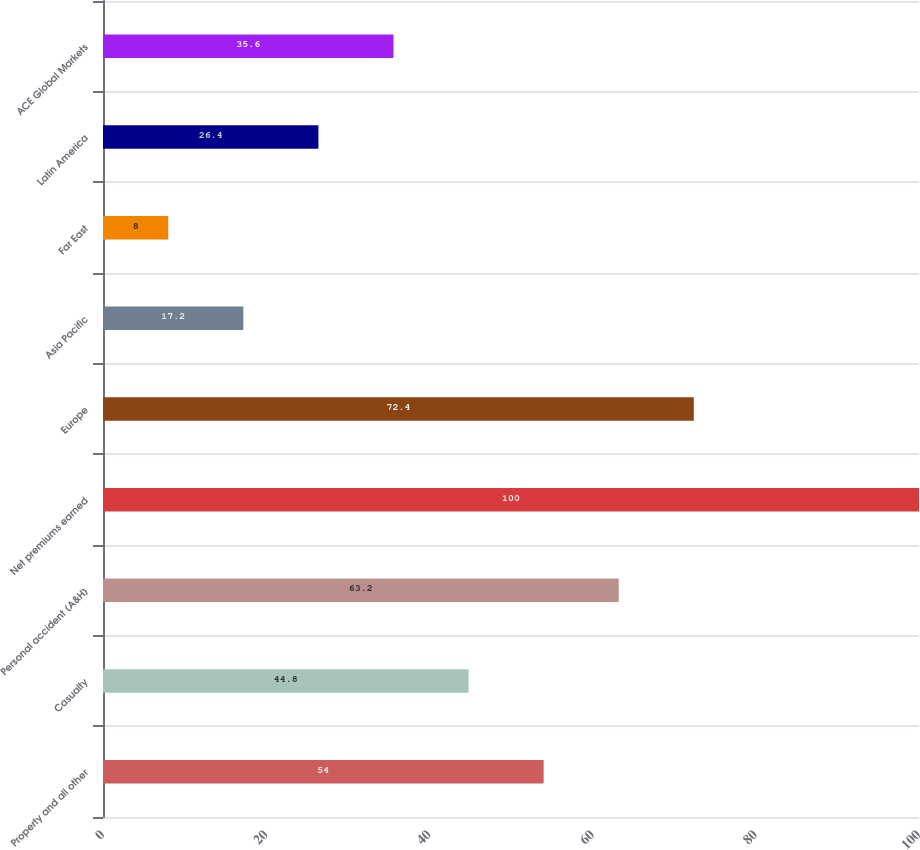Convert chart. <chart><loc_0><loc_0><loc_500><loc_500><bar_chart><fcel>Property and all other<fcel>Casualty<fcel>Personal accident (A&H)<fcel>Net premiums earned<fcel>Europe<fcel>Asia Pacific<fcel>Far East<fcel>Latin America<fcel>ACE Global Markets<nl><fcel>54<fcel>44.8<fcel>63.2<fcel>100<fcel>72.4<fcel>17.2<fcel>8<fcel>26.4<fcel>35.6<nl></chart> 